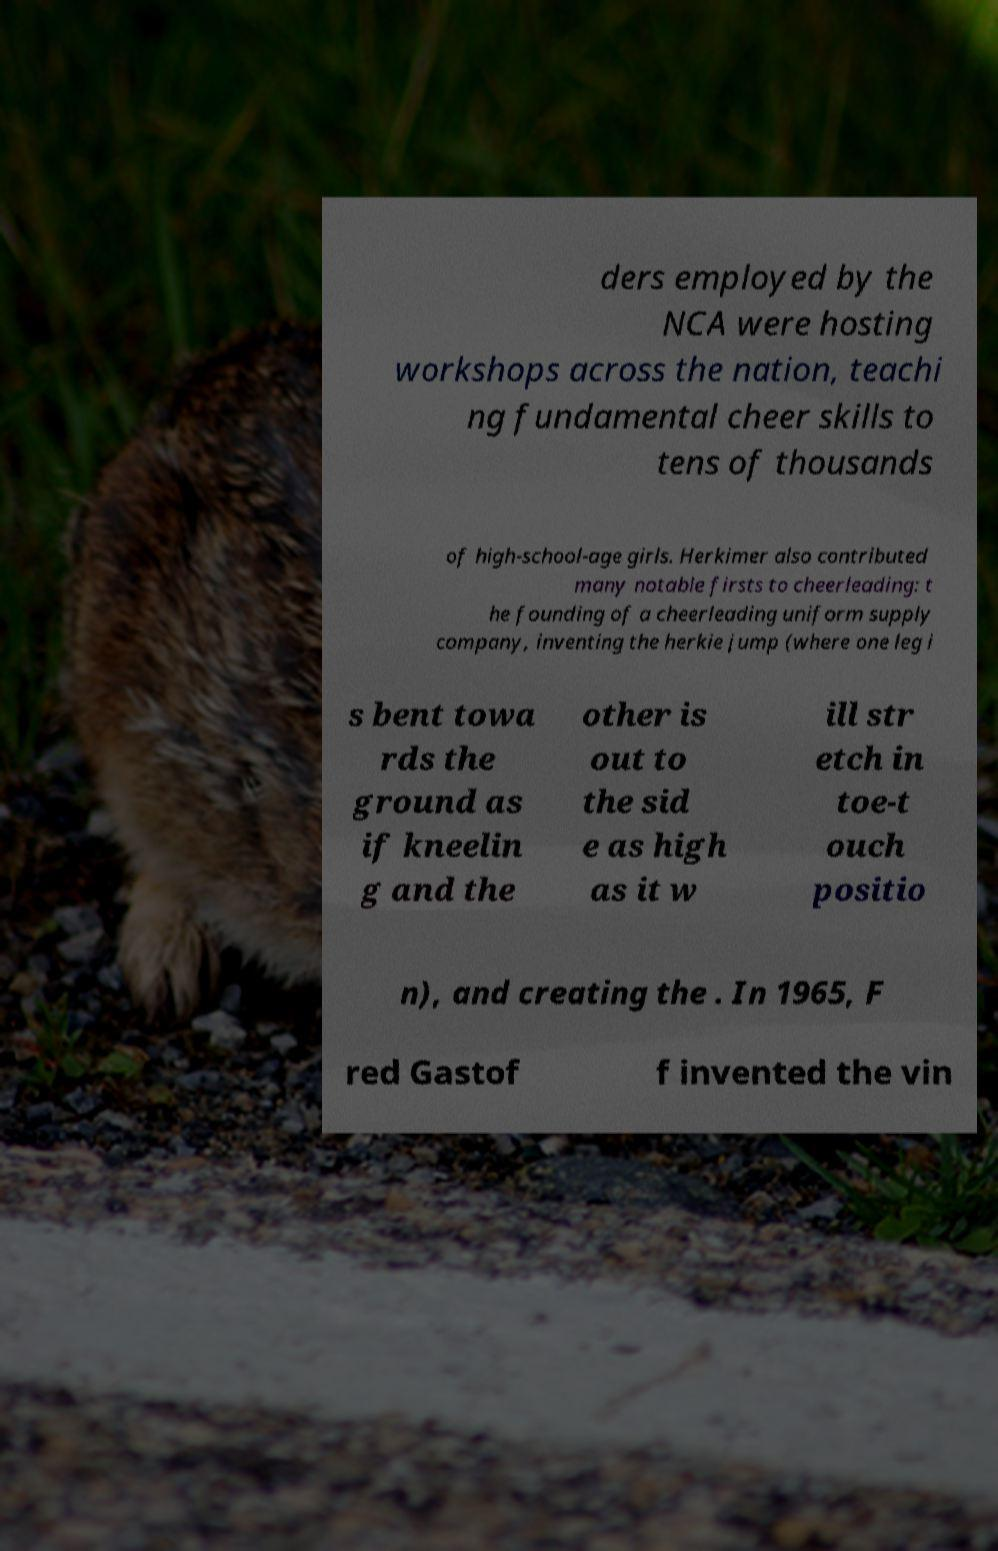I need the written content from this picture converted into text. Can you do that? ders employed by the NCA were hosting workshops across the nation, teachi ng fundamental cheer skills to tens of thousands of high-school-age girls. Herkimer also contributed many notable firsts to cheerleading: t he founding of a cheerleading uniform supply company, inventing the herkie jump (where one leg i s bent towa rds the ground as if kneelin g and the other is out to the sid e as high as it w ill str etch in toe-t ouch positio n), and creating the . In 1965, F red Gastof f invented the vin 